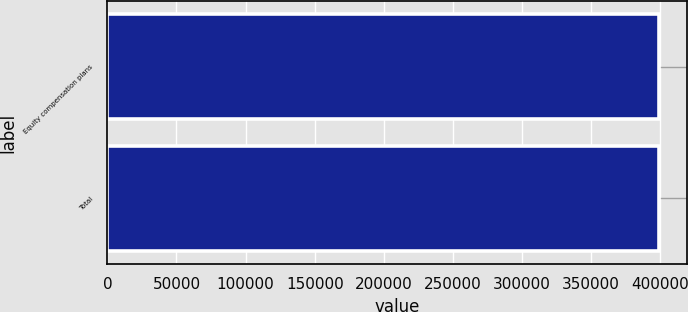Convert chart. <chart><loc_0><loc_0><loc_500><loc_500><bar_chart><fcel>Equity compensation plans<fcel>Total<nl><fcel>399165<fcel>399165<nl></chart> 